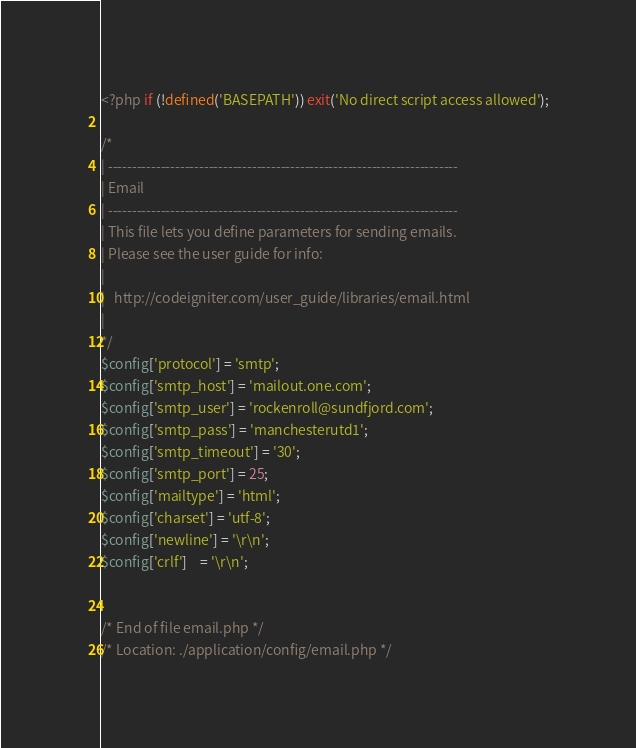<code> <loc_0><loc_0><loc_500><loc_500><_PHP_><?php if (!defined('BASEPATH')) exit('No direct script access allowed');

/*
| -------------------------------------------------------------------------
| Email
| -------------------------------------------------------------------------
| This file lets you define parameters for sending emails.
| Please see the user guide for info:
|
|	http://codeigniter.com/user_guide/libraries/email.html
|
*/
$config['protocol'] = 'smtp';
$config['smtp_host'] = 'mailout.one.com';
$config['smtp_user'] = 'rockenroll@sundfjord.com';
$config['smtp_pass'] = 'manchesterutd1';
$config['smtp_timeout'] = '30';
$config['smtp_port'] = 25;
$config['mailtype'] = 'html';
$config['charset'] = 'utf-8';
$config['newline'] = '\r\n';
$config['crlf']    = '\r\n';


/* End of file email.php */
/* Location: ./application/config/email.php */</code> 